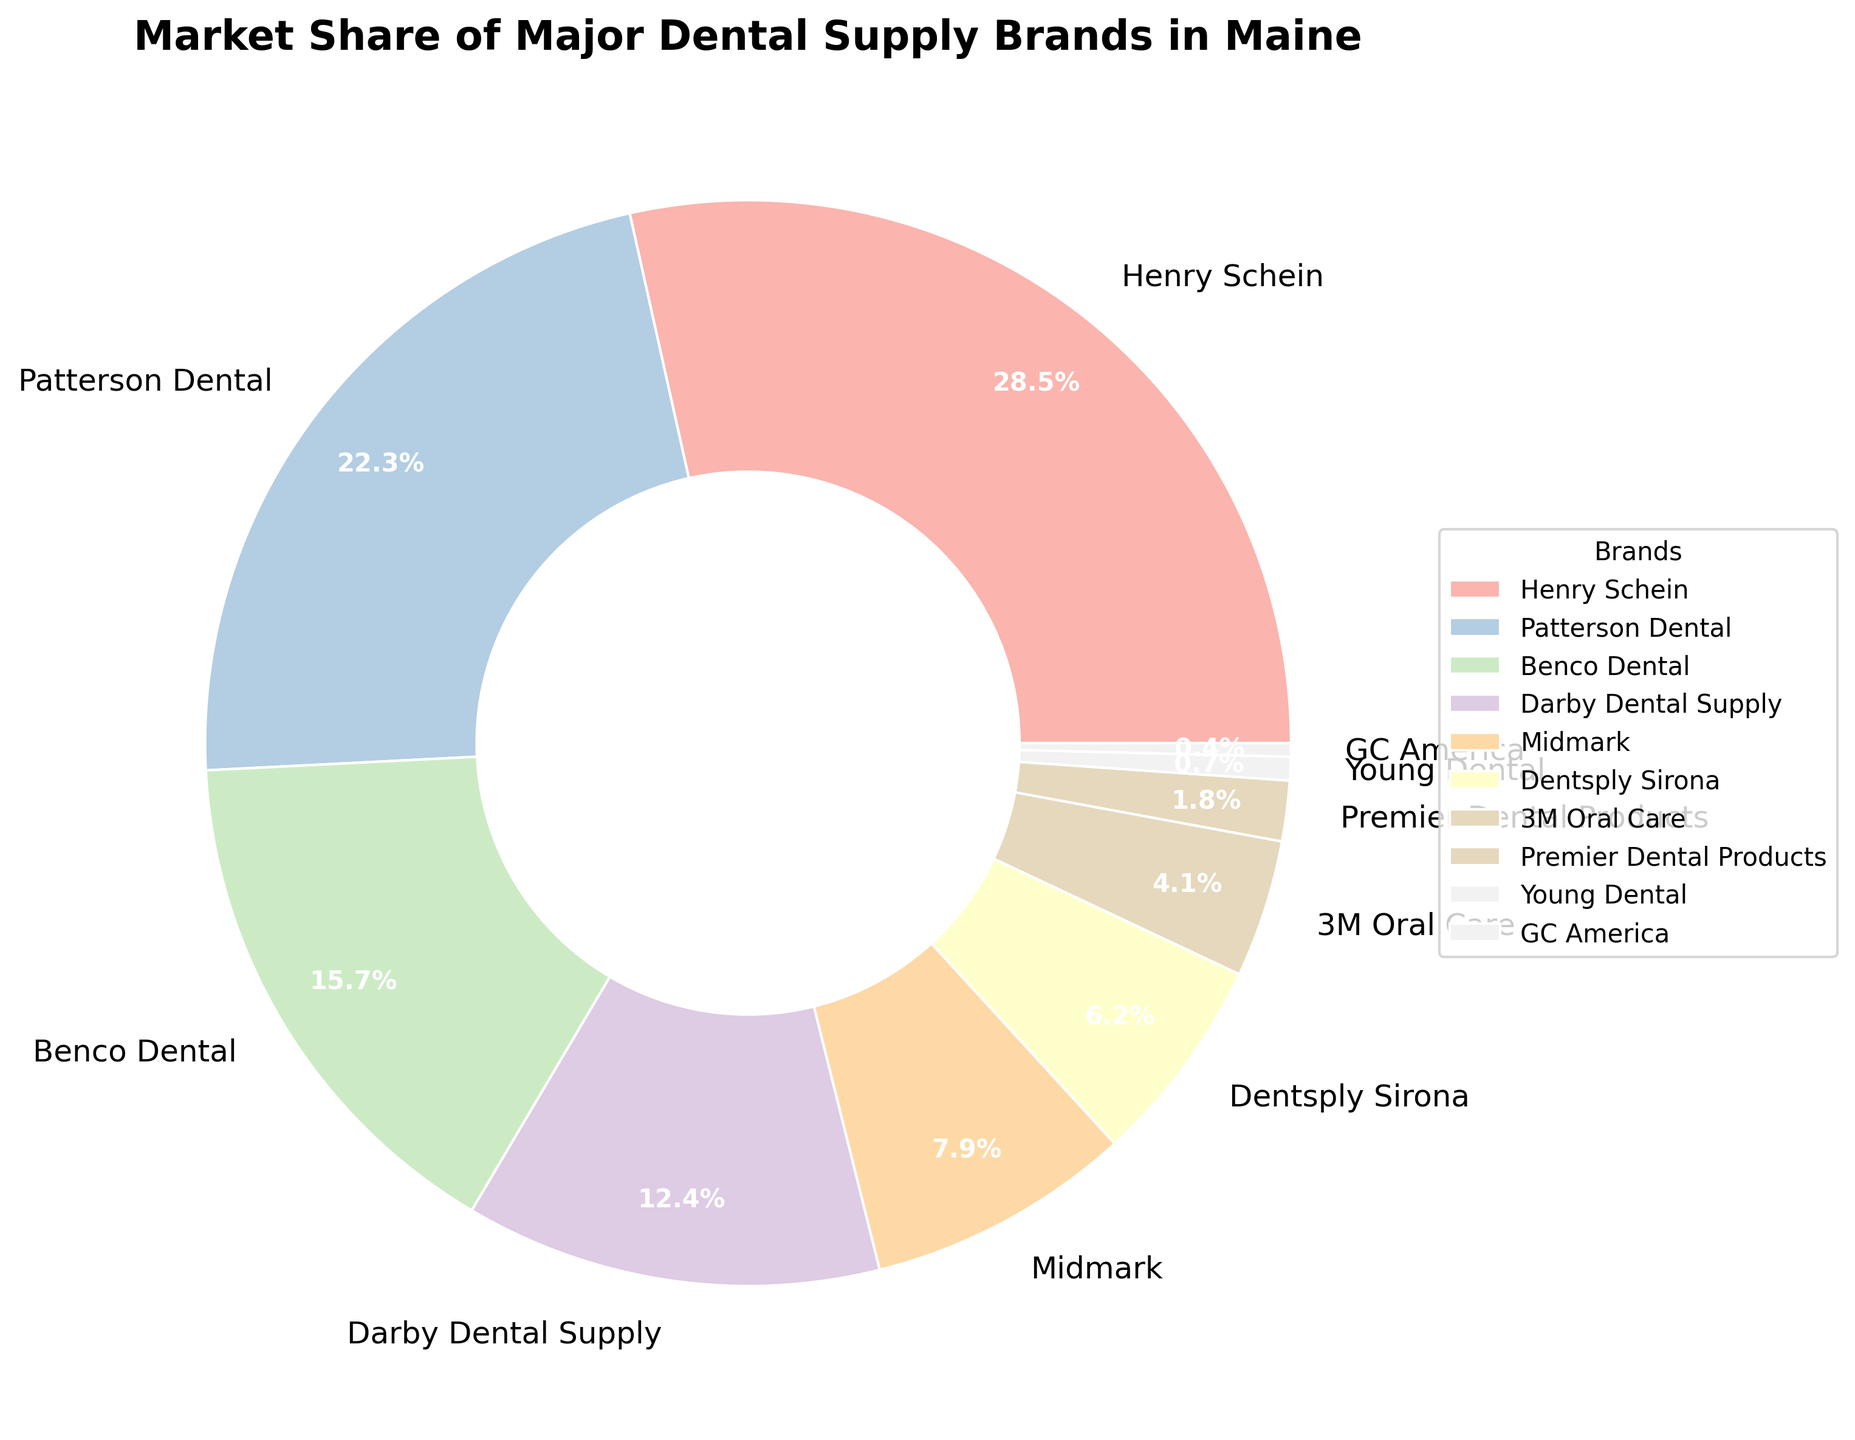What is the market share of Henry Schein? The pie chart segments are labeled with their respective market shares, and the label for Henry Schein indicates 28.5%.
Answer: 28.5% Which brand has the smallest market share? By looking at the pie chart, the smallest segment belongs to GC America, with a market share of 0.4%, as labeled.
Answer: GC America Compare the market share of Henry Schein and Patterson Dental. Which one is larger, and by how much? Henry Schein has a market share of 28.5%, and Patterson Dental has 22.3%. The difference is 28.5% - 22.3% = 6.2%.
Answer: Henry Schein by 6.2% How much combined market share do Henry Schein, Benco Dental, and Darby Dental Supply have? Sum the market shares of Henry Schein (28.5%), Benco Dental (15.7%), and Darby Dental Supply (12.4%): 28.5 + 15.7 + 12.4 = 56.6%.
Answer: 56.6% What is the average market share of the brands shown in the pie chart? Add all the market shares and divide by the number of brands: (28.5 + 22.3 + 15.7 + 12.4 + 7.9 + 6.2 + 4.1 + 1.8 + 0.7 + 0.4) / 10 = 10%.
Answer: 10% What is the combined market share of Dentsply Sirona, 3M Oral Care, and Premier Dental Products? Sum the market shares of Dentsply Sirona (6.2%), 3M Oral Care (4.1%), and Premier Dental Products (1.8%): 6.2 + 4.1 + 1.8 = 12.1%.
Answer: 12.1% Which brand has nearly half the market share of Patterson Dental? Patterson Dental has a market share of 22.3%. Half of 22.3% is around 11.15%. Darby Dental Supply, with a market share of 12.4%, is closest to this value.
Answer: Darby Dental Supply Visually, how do the colors help in distinguishing between different brands? The pie chart uses distinct colors for each segment, making it visually easier to distinguish each brand.
Answer: Different colors distinguish brands 